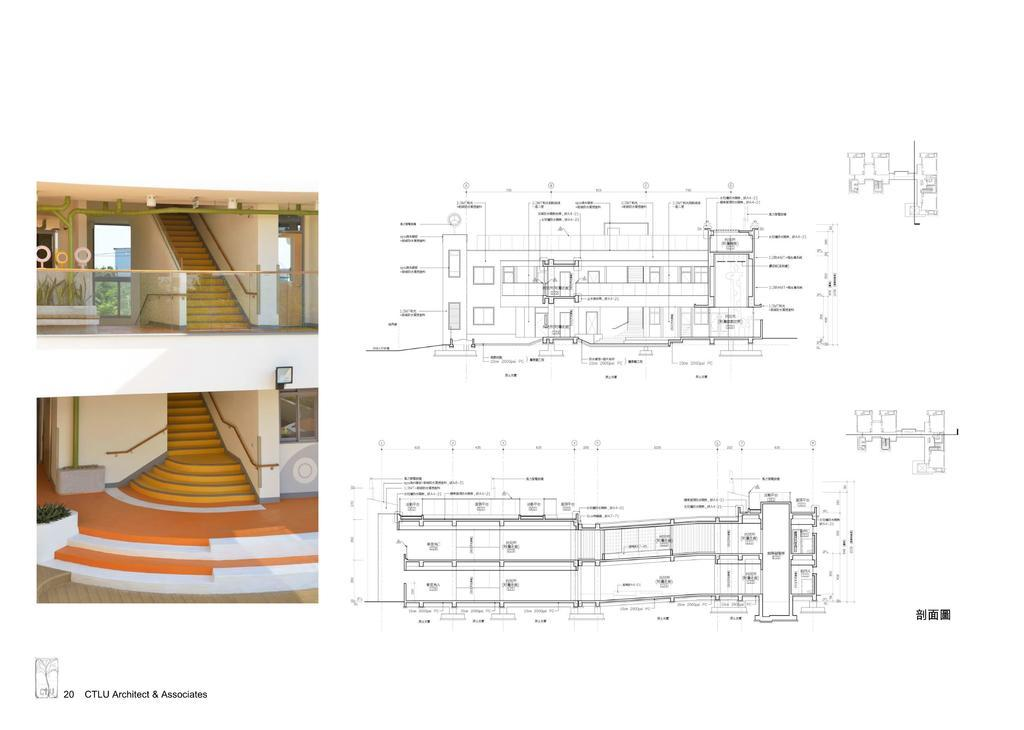What is the main subject in the center of the image? There is a drawing in the center of the image. What architectural feature is located on the left side of the image? There are stairs on the left side of the image. What type of structure is depicted in the image? There is a building in the image. Can you tell me how many offices are visible in the image? There is no mention of offices in the image; it features a drawing, stairs, and a building. Is there a bridge visible in the image? There is no bridge present in the image. 